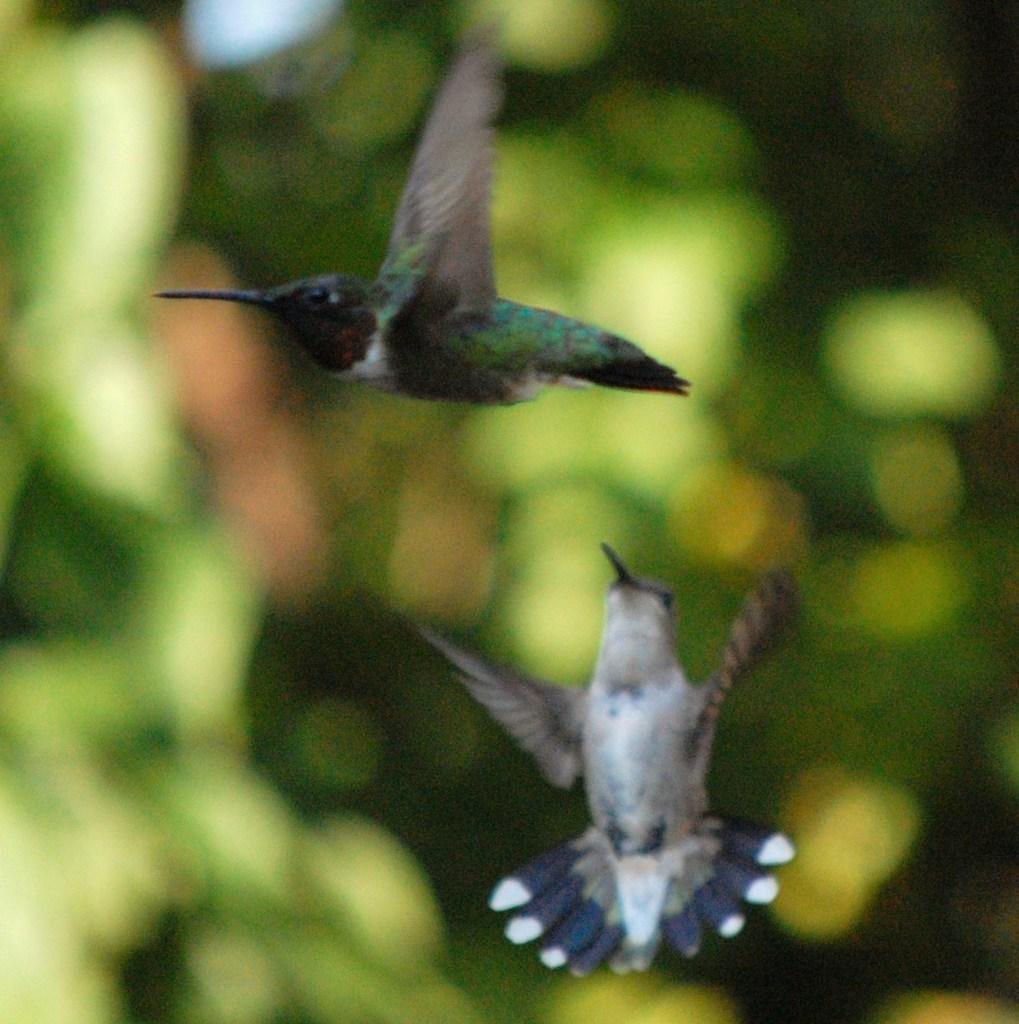What is happening in the image? There are birds flying in the image. Can you describe the background of the image? The background of the image is blurry. What type of natural environment can be seen in the image? There are trees visible in the image. What type of advertisement can be seen on the cup in the image? There is no cup present in the image, so there is no advertisement to be seen. 